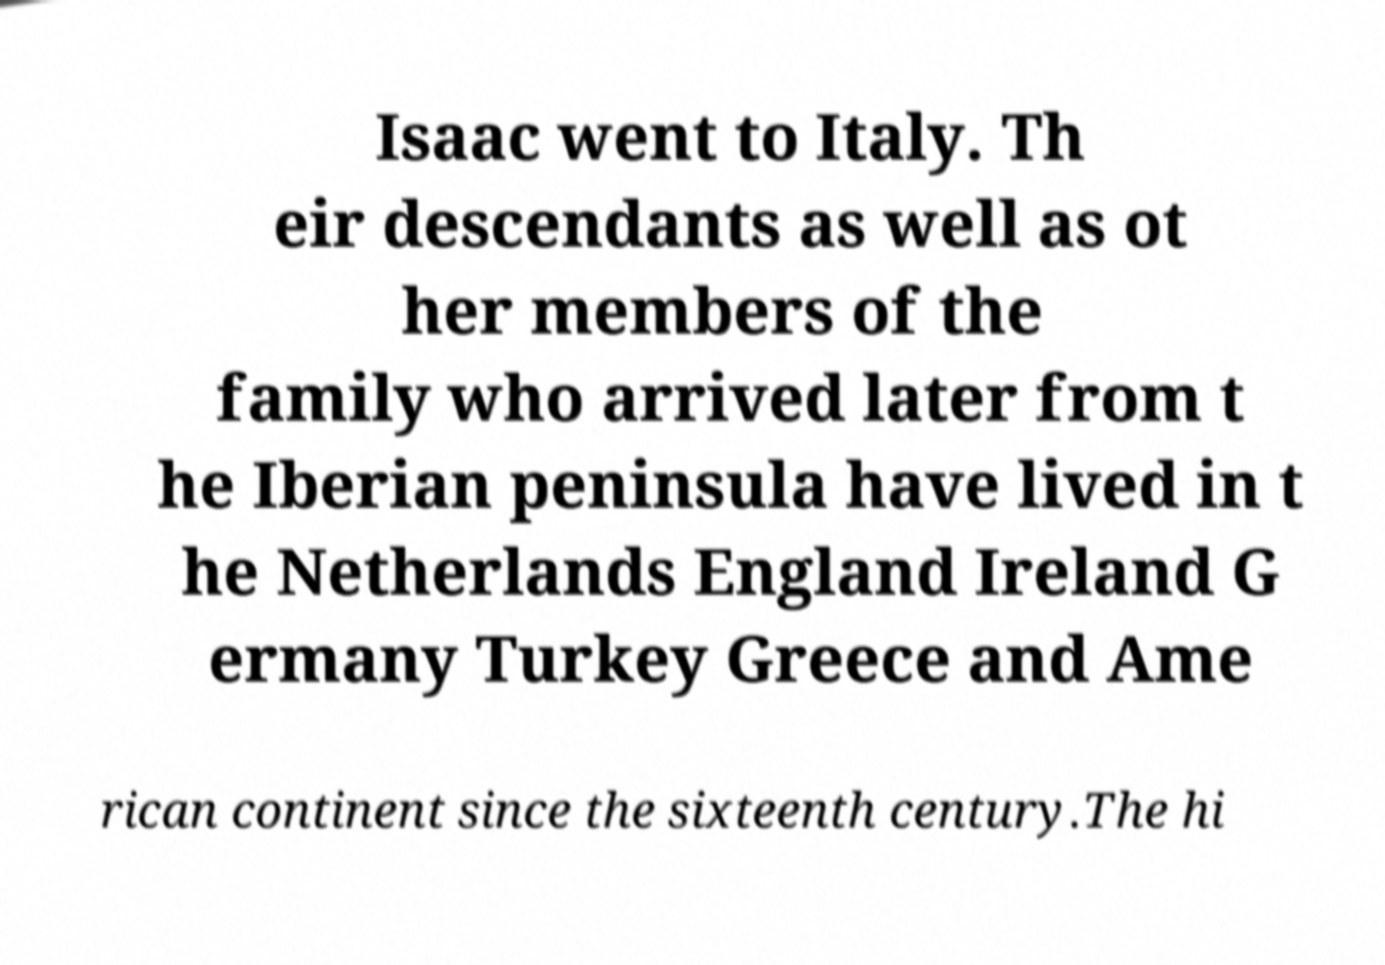What messages or text are displayed in this image? I need them in a readable, typed format. Isaac went to Italy. Th eir descendants as well as ot her members of the family who arrived later from t he Iberian peninsula have lived in t he Netherlands England Ireland G ermany Turkey Greece and Ame rican continent since the sixteenth century.The hi 